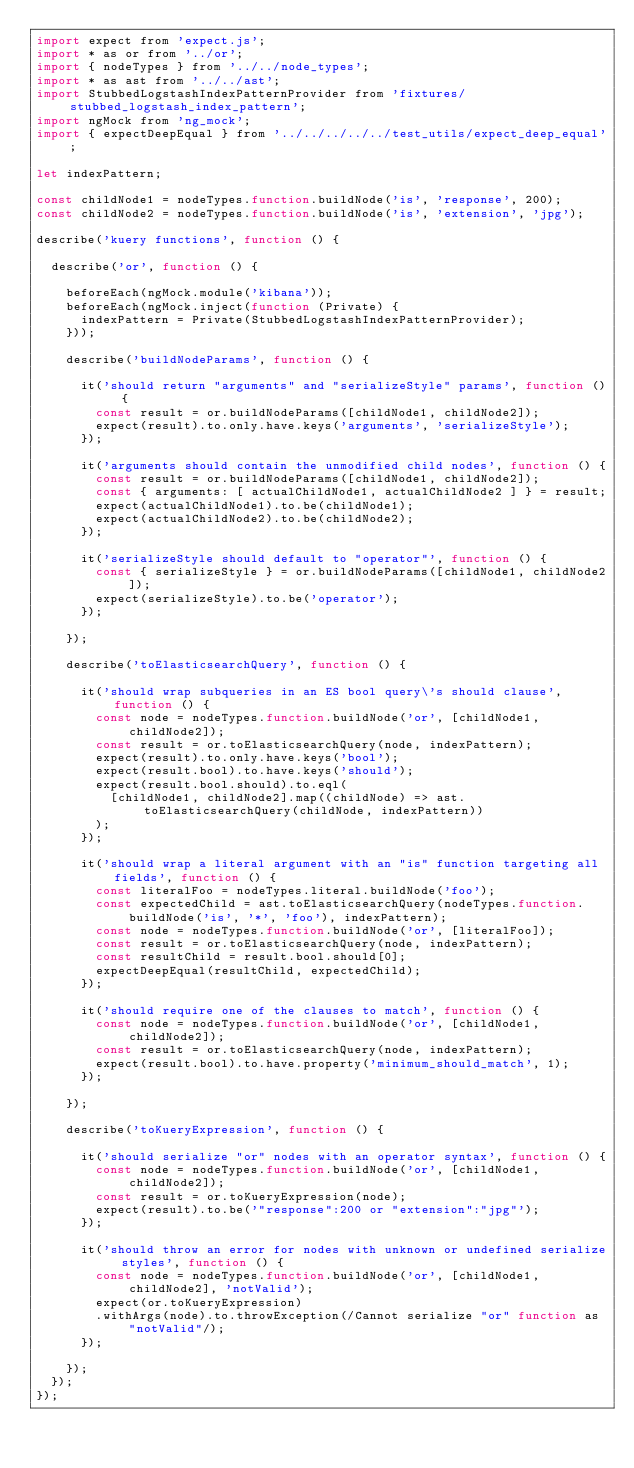Convert code to text. <code><loc_0><loc_0><loc_500><loc_500><_JavaScript_>import expect from 'expect.js';
import * as or from '../or';
import { nodeTypes } from '../../node_types';
import * as ast from '../../ast';
import StubbedLogstashIndexPatternProvider from 'fixtures/stubbed_logstash_index_pattern';
import ngMock from 'ng_mock';
import { expectDeepEqual } from '../../../../../test_utils/expect_deep_equal';

let indexPattern;

const childNode1 = nodeTypes.function.buildNode('is', 'response', 200);
const childNode2 = nodeTypes.function.buildNode('is', 'extension', 'jpg');

describe('kuery functions', function () {

  describe('or', function () {

    beforeEach(ngMock.module('kibana'));
    beforeEach(ngMock.inject(function (Private) {
      indexPattern = Private(StubbedLogstashIndexPatternProvider);
    }));

    describe('buildNodeParams', function () {

      it('should return "arguments" and "serializeStyle" params', function () {
        const result = or.buildNodeParams([childNode1, childNode2]);
        expect(result).to.only.have.keys('arguments', 'serializeStyle');
      });

      it('arguments should contain the unmodified child nodes', function () {
        const result = or.buildNodeParams([childNode1, childNode2]);
        const { arguments: [ actualChildNode1, actualChildNode2 ] } = result;
        expect(actualChildNode1).to.be(childNode1);
        expect(actualChildNode2).to.be(childNode2);
      });

      it('serializeStyle should default to "operator"', function () {
        const { serializeStyle } = or.buildNodeParams([childNode1, childNode2]);
        expect(serializeStyle).to.be('operator');
      });

    });

    describe('toElasticsearchQuery', function () {

      it('should wrap subqueries in an ES bool query\'s should clause', function () {
        const node = nodeTypes.function.buildNode('or', [childNode1, childNode2]);
        const result = or.toElasticsearchQuery(node, indexPattern);
        expect(result).to.only.have.keys('bool');
        expect(result.bool).to.have.keys('should');
        expect(result.bool.should).to.eql(
          [childNode1, childNode2].map((childNode) => ast.toElasticsearchQuery(childNode, indexPattern))
        );
      });

      it('should wrap a literal argument with an "is" function targeting all fields', function () {
        const literalFoo = nodeTypes.literal.buildNode('foo');
        const expectedChild = ast.toElasticsearchQuery(nodeTypes.function.buildNode('is', '*', 'foo'), indexPattern);
        const node = nodeTypes.function.buildNode('or', [literalFoo]);
        const result = or.toElasticsearchQuery(node, indexPattern);
        const resultChild = result.bool.should[0];
        expectDeepEqual(resultChild, expectedChild);
      });

      it('should require one of the clauses to match', function () {
        const node = nodeTypes.function.buildNode('or', [childNode1, childNode2]);
        const result = or.toElasticsearchQuery(node, indexPattern);
        expect(result.bool).to.have.property('minimum_should_match', 1);
      });

    });

    describe('toKueryExpression', function () {

      it('should serialize "or" nodes with an operator syntax', function () {
        const node = nodeTypes.function.buildNode('or', [childNode1, childNode2]);
        const result = or.toKueryExpression(node);
        expect(result).to.be('"response":200 or "extension":"jpg"');
      });

      it('should throw an error for nodes with unknown or undefined serialize styles', function () {
        const node = nodeTypes.function.buildNode('or', [childNode1, childNode2], 'notValid');
        expect(or.toKueryExpression)
        .withArgs(node).to.throwException(/Cannot serialize "or" function as "notValid"/);
      });

    });
  });
});
</code> 